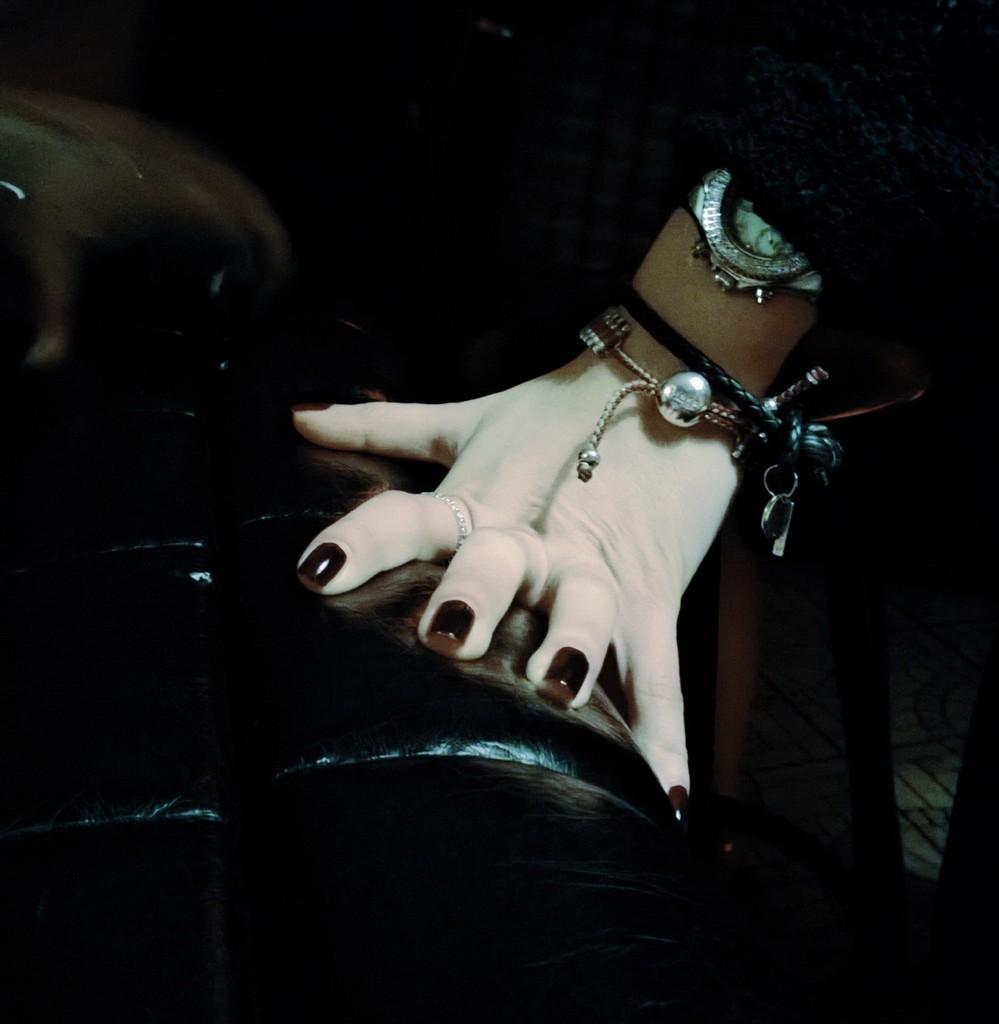What part of the person's body is visible in the image? There is a person's hand in the image. What is the hand placed on? The hand is on a black colored object. What color is the dress the person is wearing? The person is wearing a black colored dress. Can you identify any accessories the person is wearing? The person is wearing a watch. What type of stamp can be seen on the person's hand in the image? There is no stamp visible on the person's hand in the image. 